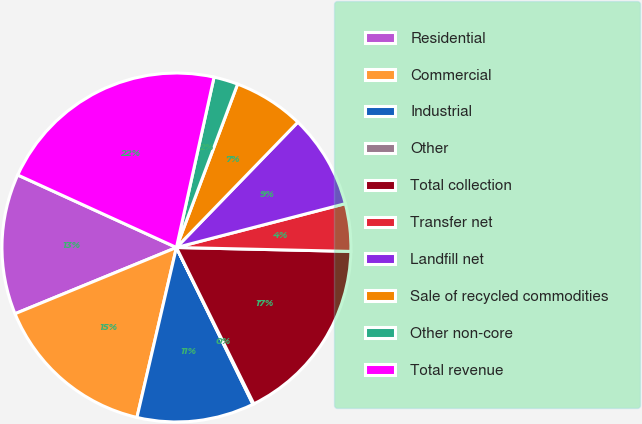Convert chart to OTSL. <chart><loc_0><loc_0><loc_500><loc_500><pie_chart><fcel>Residential<fcel>Commercial<fcel>Industrial<fcel>Other<fcel>Total collection<fcel>Transfer net<fcel>Landfill net<fcel>Sale of recycled commodities<fcel>Other non-core<fcel>Total revenue<nl><fcel>13.02%<fcel>15.17%<fcel>10.86%<fcel>0.09%<fcel>17.33%<fcel>4.4%<fcel>8.71%<fcel>6.55%<fcel>2.24%<fcel>21.64%<nl></chart> 